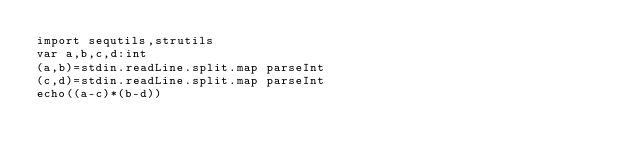Convert code to text. <code><loc_0><loc_0><loc_500><loc_500><_Nim_>import sequtils,strutils
var a,b,c,d:int
(a,b)=stdin.readLine.split.map parseInt
(c,d)=stdin.readLine.split.map parseInt
echo((a-c)*(b-d))</code> 